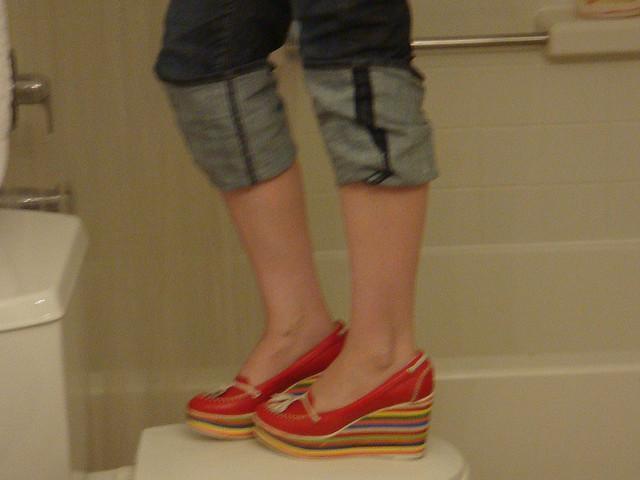How many toilets are in the photo?
Give a very brief answer. 2. How many red chairs are there?
Give a very brief answer. 0. 